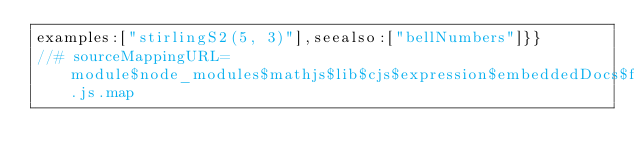<code> <loc_0><loc_0><loc_500><loc_500><_JavaScript_>examples:["stirlingS2(5, 3)"],seealso:["bellNumbers"]}}
//# sourceMappingURL=module$node_modules$mathjs$lib$cjs$expression$embeddedDocs$function$combinatorics$stirlingS2.js.map
</code> 